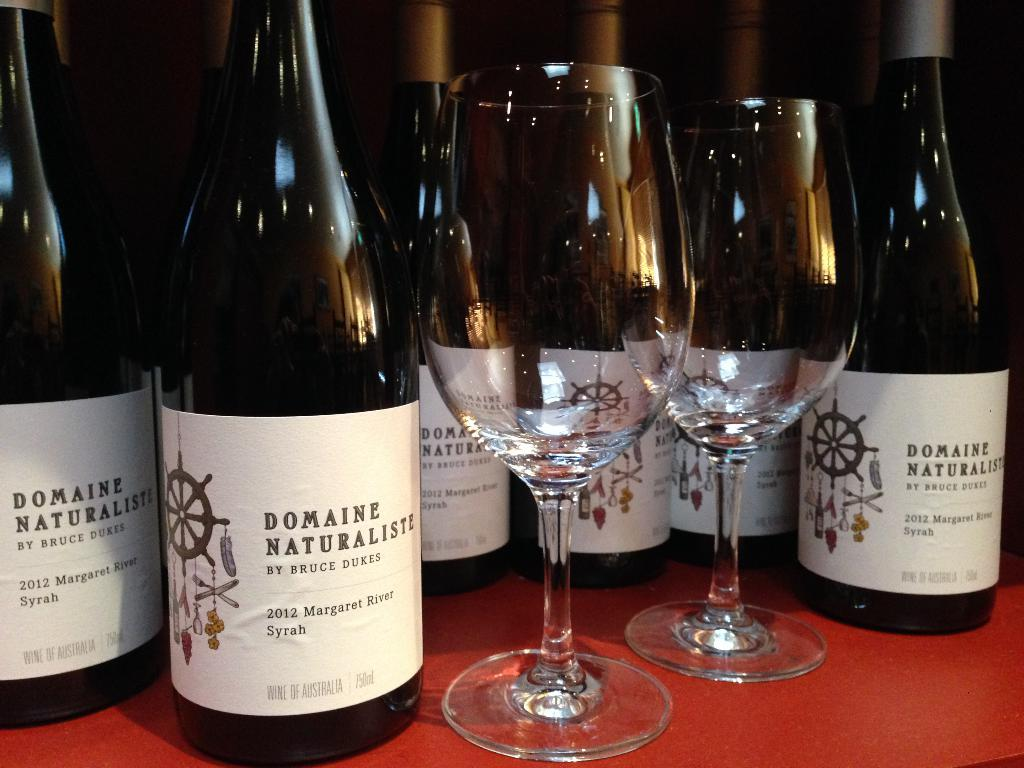<image>
Write a terse but informative summary of the picture. Bottles of Domaine Naturaliste wine and some glasses 